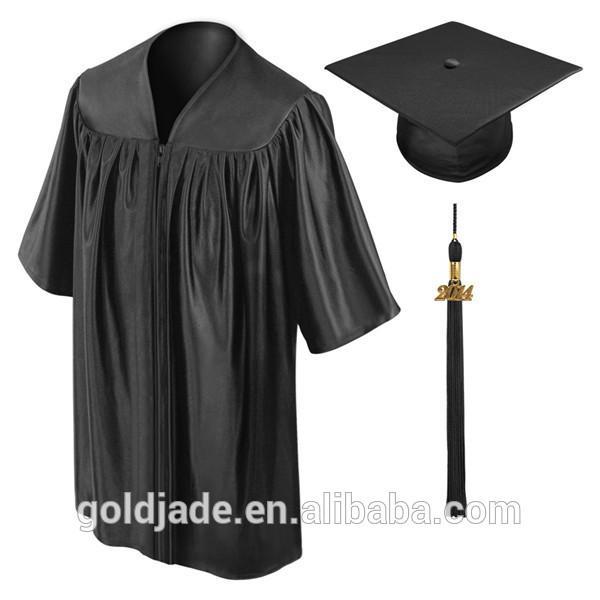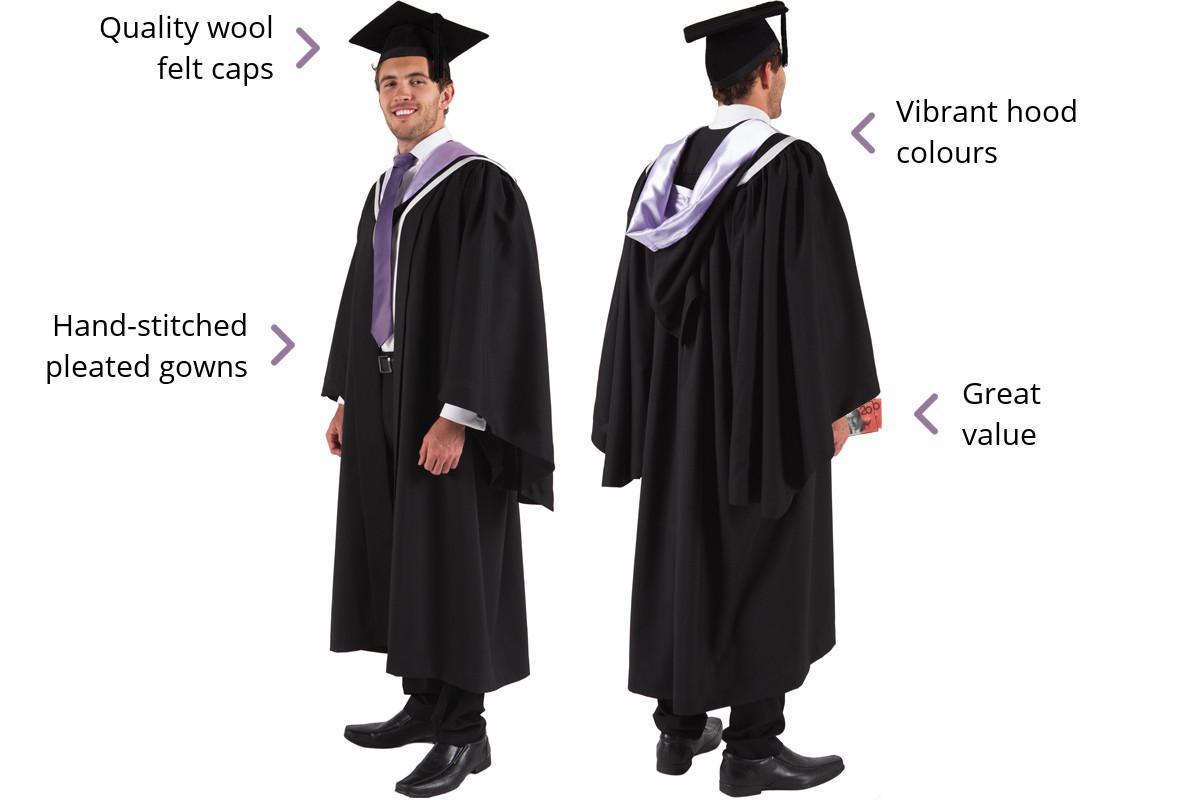The first image is the image on the left, the second image is the image on the right. Analyze the images presented: Is the assertion "An image includes a young man standing at a leftward-turned angle, modeling a graduation robe and cap." valid? Answer yes or no. Yes. The first image is the image on the left, the second image is the image on the right. For the images displayed, is the sentence "There are more unworn clothes than people." factually correct? Answer yes or no. No. 